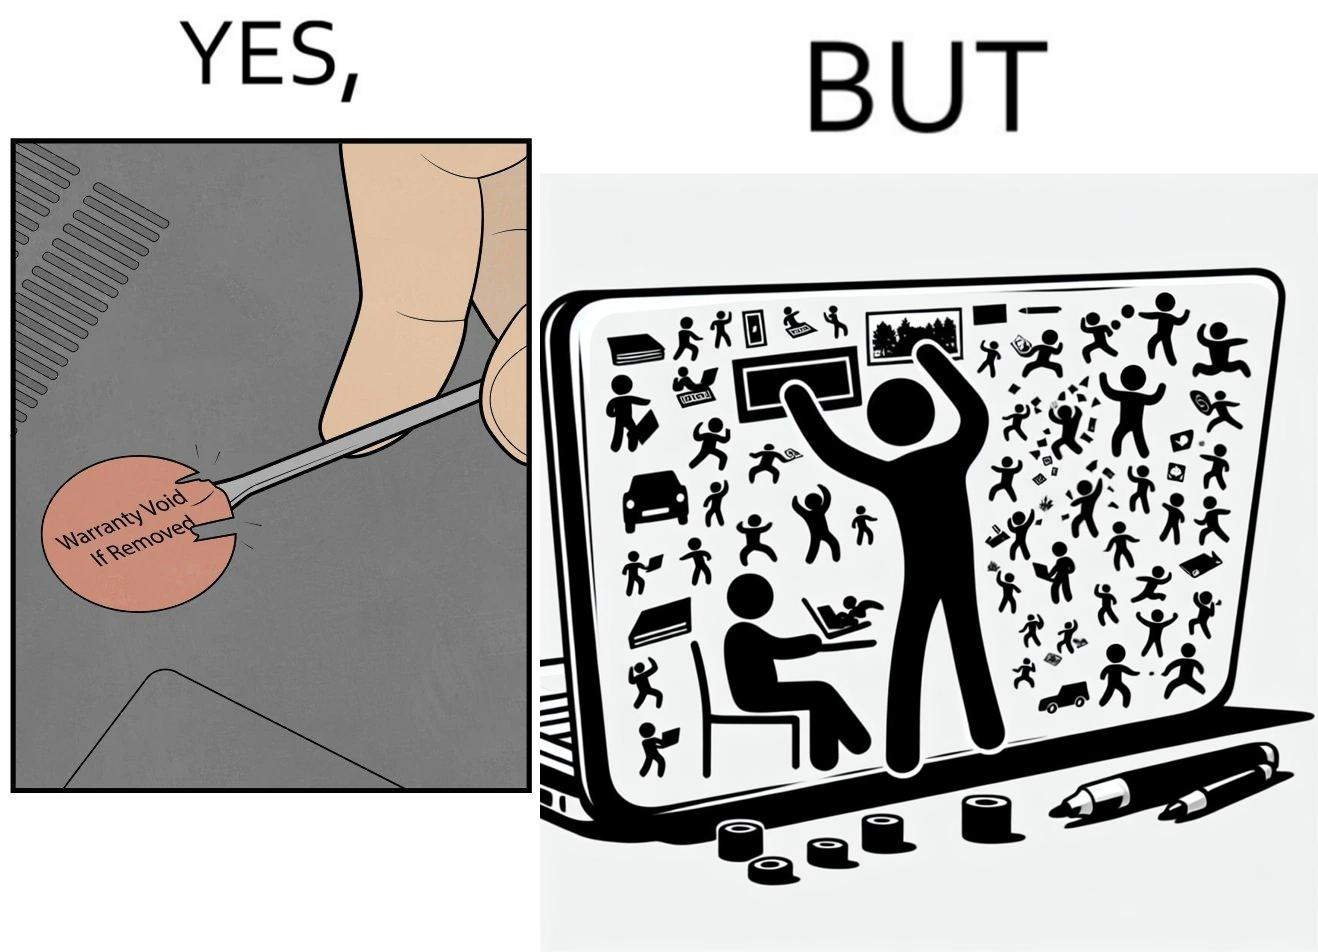Is this a satirical image? Yes, this image is satirical. 